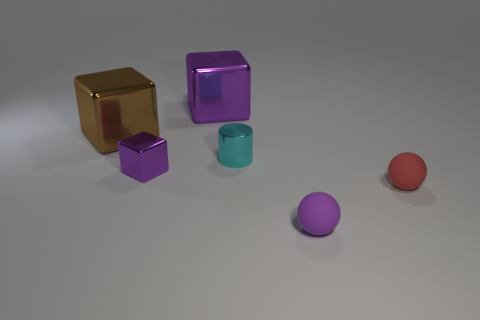Do the purple cube behind the small cyan metal cylinder and the big brown block have the same material?
Offer a terse response. Yes. What number of objects are on the right side of the cyan object and to the left of the tiny purple metal cube?
Your response must be concise. 0. There is a small object left of the purple metal block behind the purple shiny block in front of the cyan metallic object; what color is it?
Keep it short and to the point. Purple. How many other objects are there of the same shape as the tiny red object?
Offer a very short reply. 1. There is a purple metal object in front of the small cyan cylinder; is there a large purple cube in front of it?
Make the answer very short. No. What number of shiny things are either small cubes or cyan cylinders?
Provide a short and direct response. 2. What material is the purple thing that is both right of the small block and in front of the large purple metallic thing?
Make the answer very short. Rubber. Is there a purple metal block that is left of the purple metallic block that is behind the small metal thing behind the tiny purple block?
Offer a very short reply. Yes. What is the shape of the tiny thing that is the same material as the cylinder?
Offer a very short reply. Cube. Is the number of cyan shiny cylinders that are in front of the red object less than the number of matte objects that are behind the small purple sphere?
Offer a terse response. Yes. 